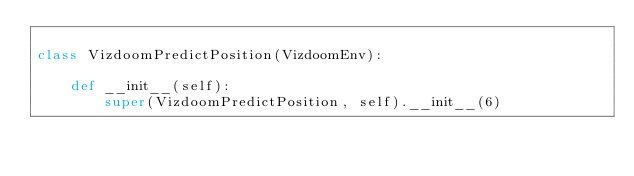Convert code to text. <code><loc_0><loc_0><loc_500><loc_500><_Python_>
class VizdoomPredictPosition(VizdoomEnv):

    def __init__(self):
        super(VizdoomPredictPosition, self).__init__(6)
</code> 